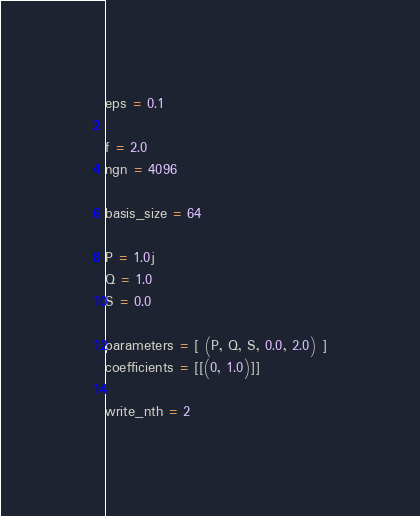<code> <loc_0><loc_0><loc_500><loc_500><_Python_>
eps = 0.1

f = 2.0
ngn = 4096

basis_size = 64

P = 1.0j
Q = 1.0
S = 0.0

parameters = [ (P, Q, S, 0.0, 2.0) ]
coefficients = [[(0, 1.0)]]

write_nth = 2
</code> 